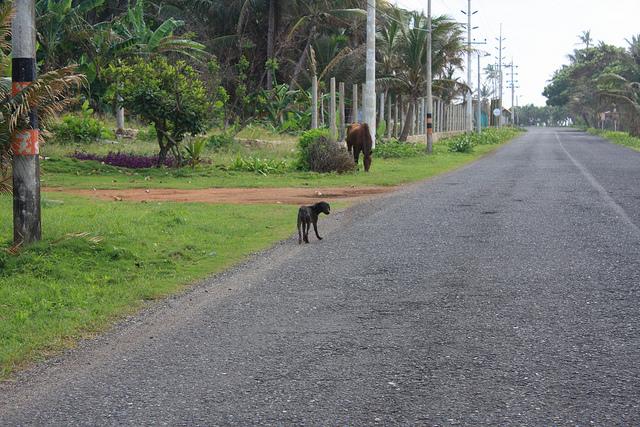Are there any cars in the street?
Keep it brief. No. Are there palm trees in the picture?
Write a very short answer. Yes. Are the animals contained?
Short answer required. No. 